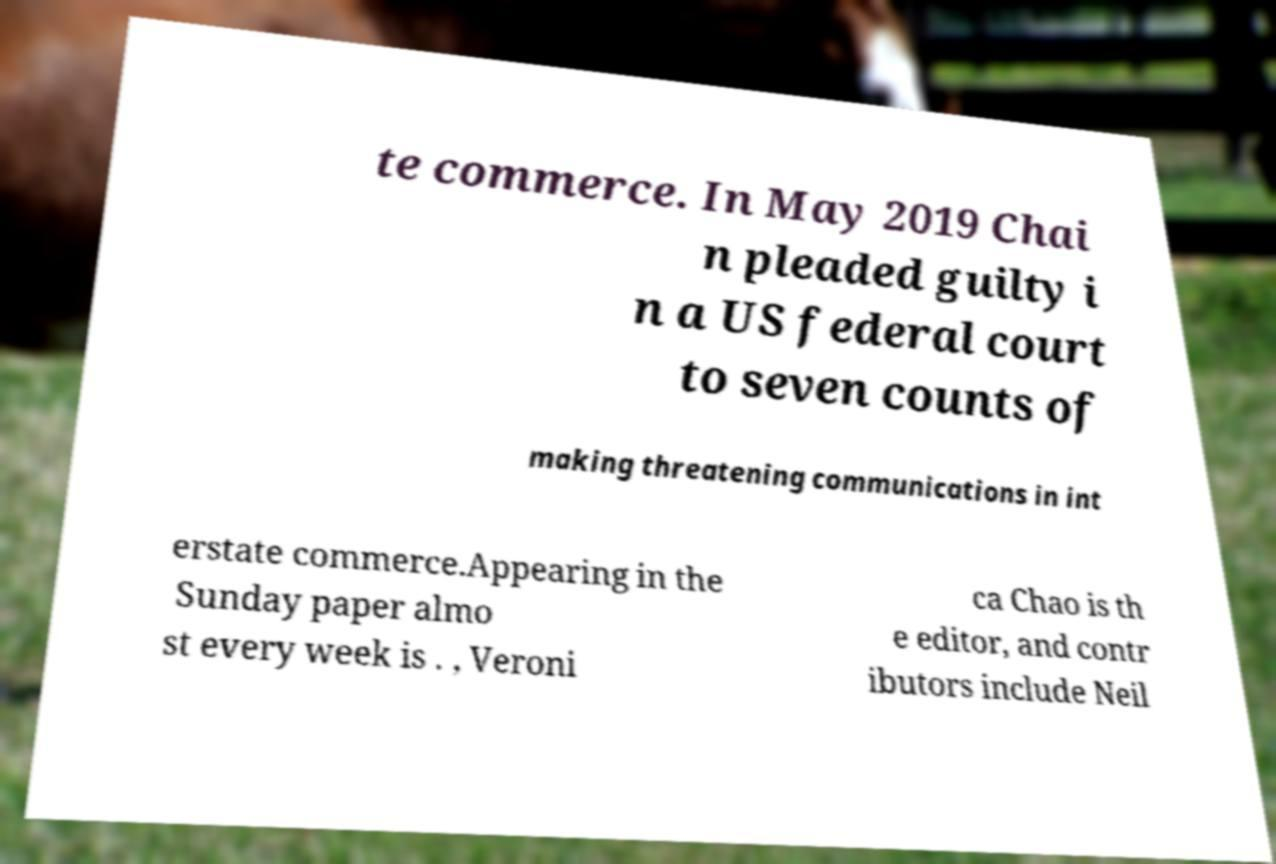Can you accurately transcribe the text from the provided image for me? te commerce. In May 2019 Chai n pleaded guilty i n a US federal court to seven counts of making threatening communications in int erstate commerce.Appearing in the Sunday paper almo st every week is . , Veroni ca Chao is th e editor, and contr ibutors include Neil 